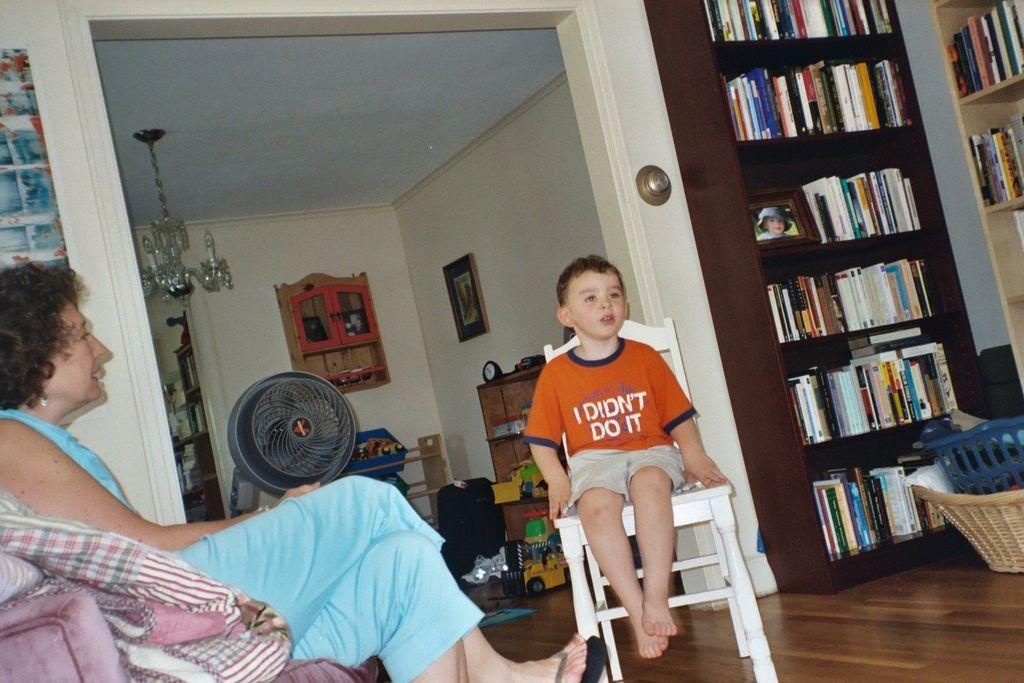Who didn't do it?
Your response must be concise. I. What does the orange shirt say?
Offer a very short reply. I didn't do it. 